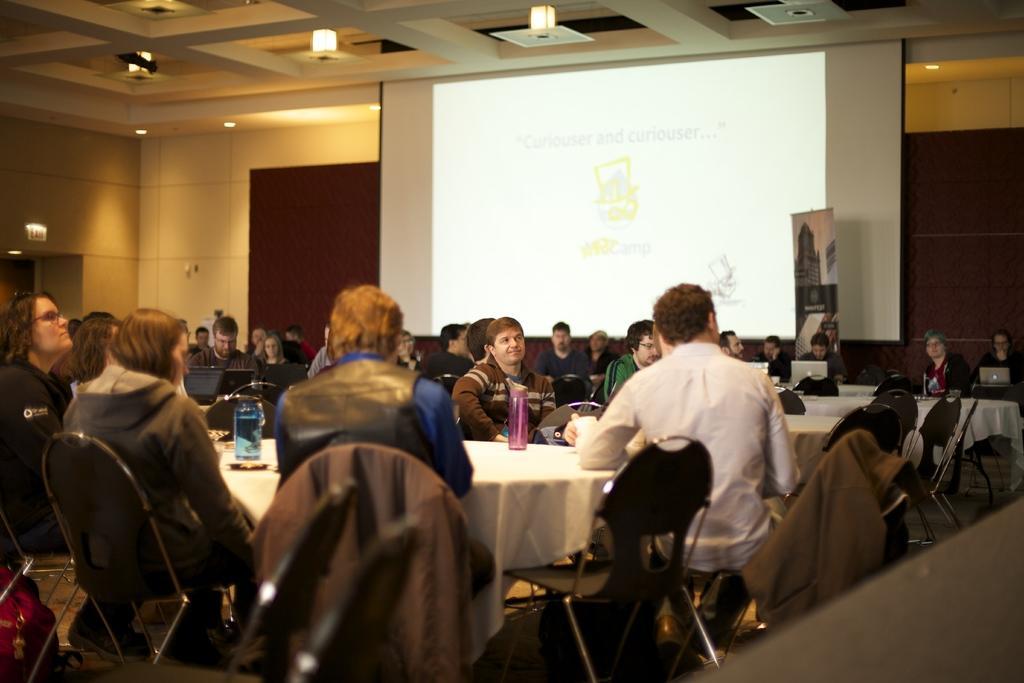Could you give a brief overview of what you see in this image? This is a picture of a meeting room were we see people seated on the chairs and we see a projector screen. 